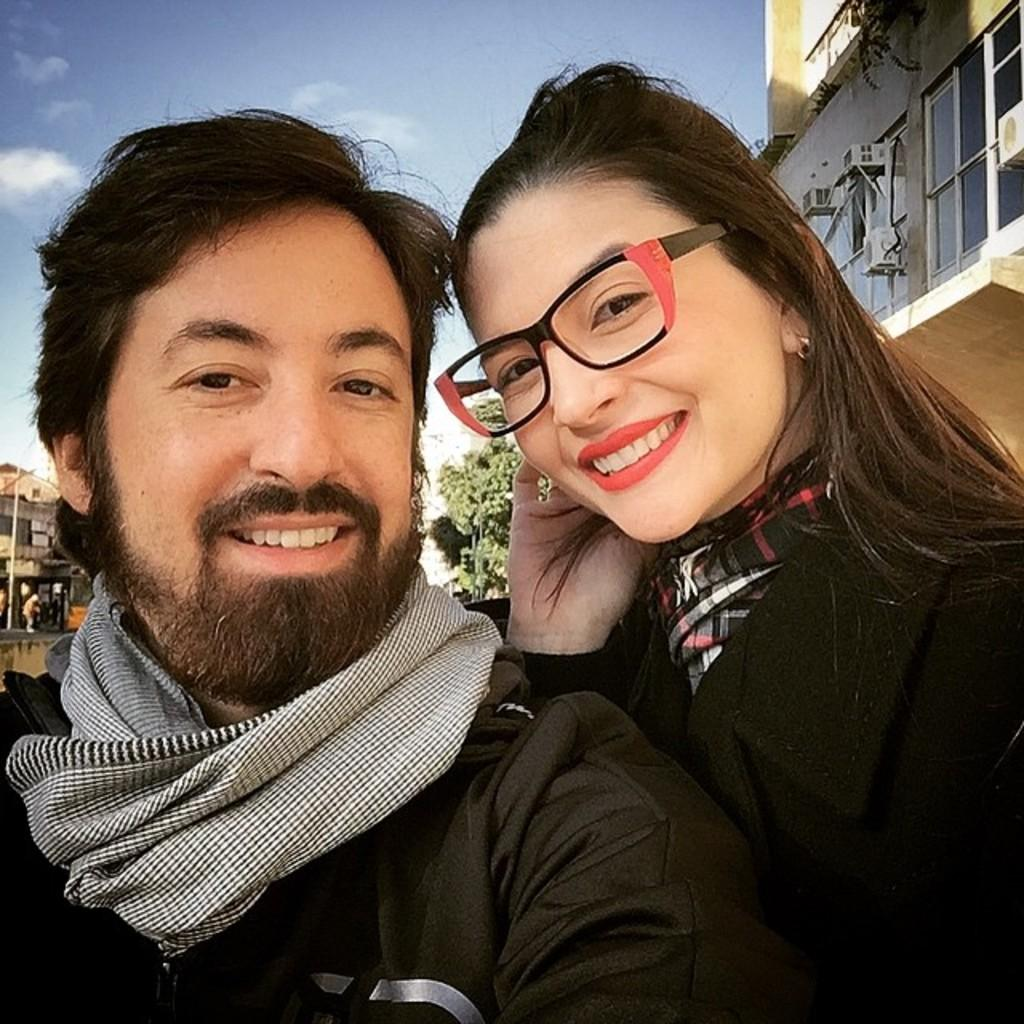How many people are in the image? There are two people in the image. What are the people doing in the image? The people are smiling. What color are the clothes worn by the people in the image? The people are wearing black color dress. What can be seen in the background of the image? There are buildings, glass windows, and a pole visible in the background. What is the color of the sky in the image? The sky is blue and white in color. What type of bomb can be seen in the image? There is no bomb present in the image. What kind of spoon is being used by the people in the image? There are no spoons visible in the image. 